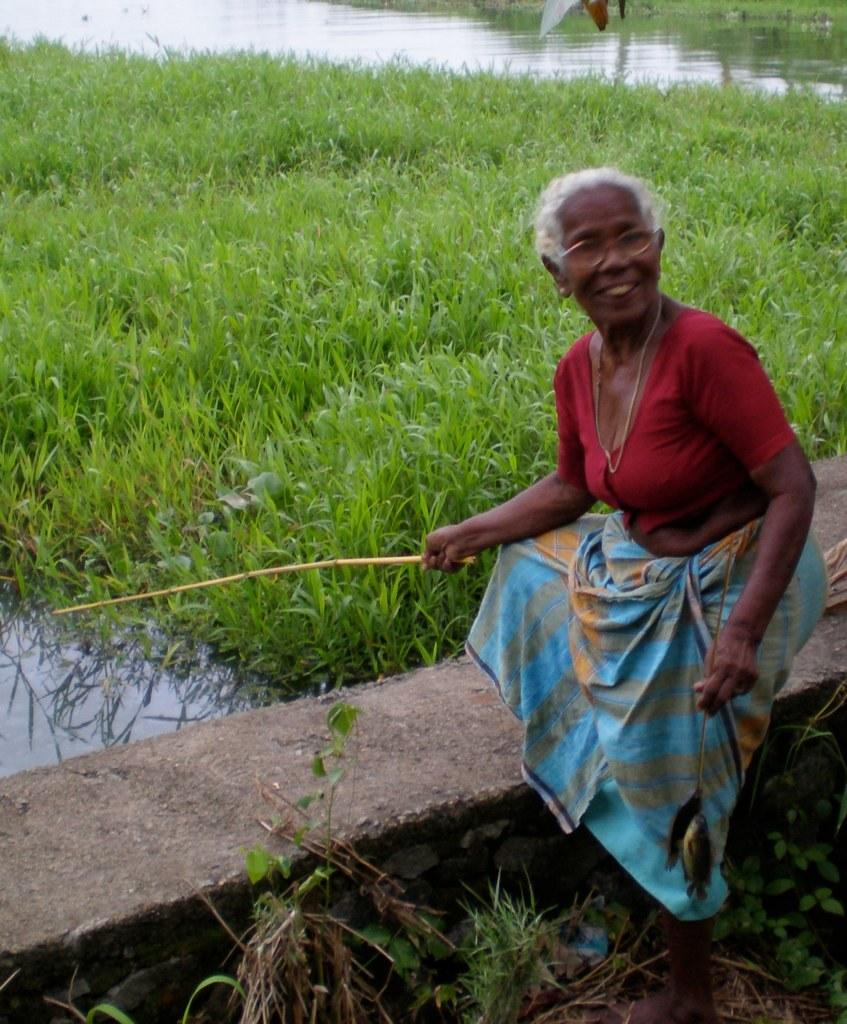Who is present in the image? There is a woman in the image. What is the woman doing in the image? The woman is standing near a wall and holding a stick. What can be seen on the left side of the image? There is water visible on the left side of the image. What type of vegetation is present beside the water? There is grass visible beside the water. What type of baseball play is the woman attempting in the image? There is no baseball play present in the image; the woman is holding a stick and standing near a wall. 